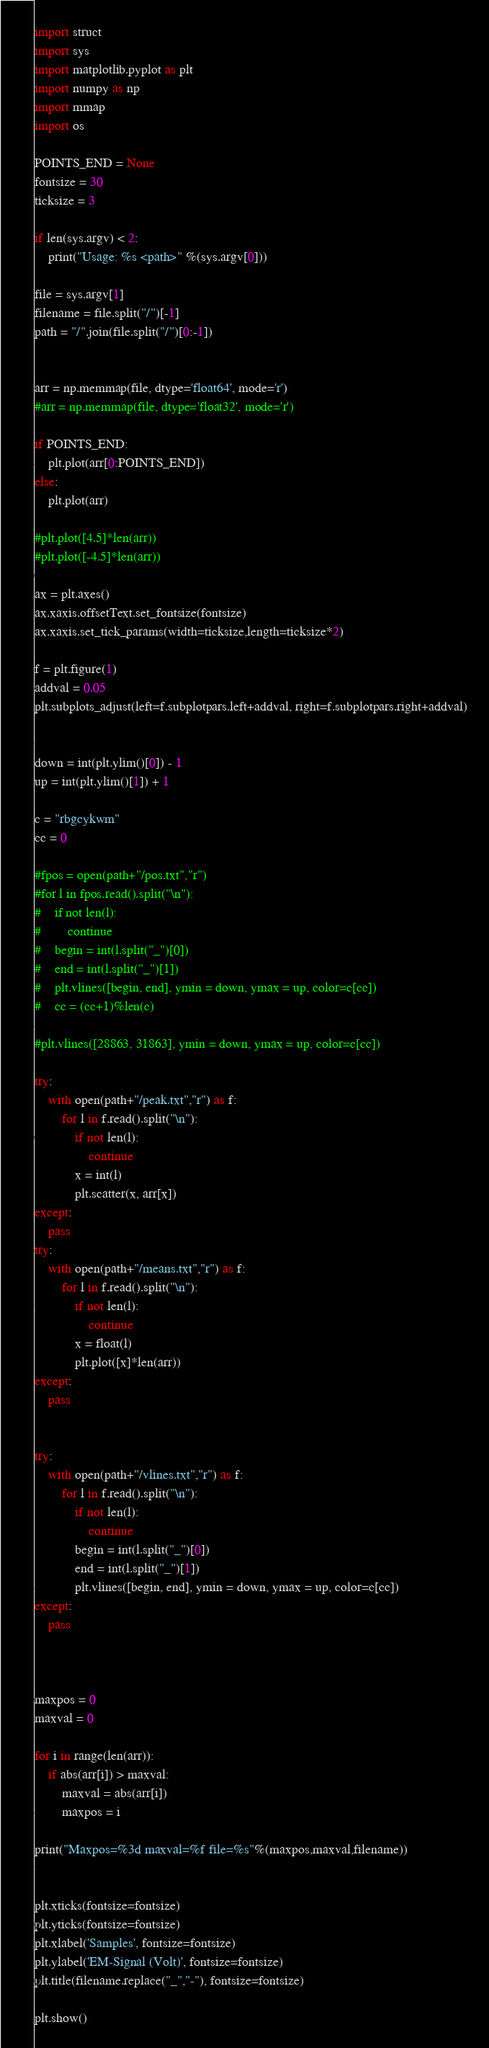<code> <loc_0><loc_0><loc_500><loc_500><_Python_>import struct
import sys
import matplotlib.pyplot as plt
import numpy as np
import mmap
import os

POINTS_END = None
fontsize = 30
ticksize = 3

if len(sys.argv) < 2:
    print("Usage: %s <path>" %(sys.argv[0]))

file = sys.argv[1]
filename = file.split("/")[-1]
path = "/".join(file.split("/")[0:-1])


arr = np.memmap(file, dtype='float64', mode='r')
#arr = np.memmap(file, dtype='float32', mode='r')

if POINTS_END:
    plt.plot(arr[0:POINTS_END])
else:
    plt.plot(arr)
    
#plt.plot([4.5]*len(arr))
#plt.plot([-4.5]*len(arr))

ax = plt.axes()
ax.xaxis.offsetText.set_fontsize(fontsize)
ax.xaxis.set_tick_params(width=ticksize,length=ticksize*2)

f = plt.figure(1)
addval = 0.05
plt.subplots_adjust(left=f.subplotpars.left+addval, right=f.subplotpars.right+addval)


down = int(plt.ylim()[0]) - 1
up = int(plt.ylim()[1]) + 1

c = "rbgcykwm"
cc = 0

#fpos = open(path+"/pos.txt","r")
#for l in fpos.read().split("\n"):
#    if not len(l):
#        continue
#    begin = int(l.split("_")[0])
#    end = int(l.split("_")[1])
#    plt.vlines([begin, end], ymin = down, ymax = up, color=c[cc])
#    cc = (cc+1)%len(c)

#plt.vlines([28863, 31863], ymin = down, ymax = up, color=c[cc])

try:
    with open(path+"/peak.txt","r") as f:
        for l in f.read().split("\n"):
            if not len(l):
                continue
            x = int(l)
            plt.scatter(x, arr[x])
except:
    pass
try:
    with open(path+"/means.txt","r") as f:
        for l in f.read().split("\n"):
            if not len(l):
                continue
            x = float(l)
            plt.plot([x]*len(arr))
except:
    pass


try:
    with open(path+"/vlines.txt","r") as f:
        for l in f.read().split("\n"):
            if not len(l):
                continue
            begin = int(l.split("_")[0])
            end = int(l.split("_")[1])
            plt.vlines([begin, end], ymin = down, ymax = up, color=c[cc])
except:
    pass



maxpos = 0
maxval = 0

for i in range(len(arr)):
    if abs(arr[i]) > maxval:
        maxval = abs(arr[i])
        maxpos = i

print("Maxpos=%3d maxval=%f file=%s"%(maxpos,maxval,filename))


plt.xticks(fontsize=fontsize)
plt.yticks(fontsize=fontsize)
plt.xlabel('Samples', fontsize=fontsize)
plt.ylabel('EM-Signal (Volt)', fontsize=fontsize)
plt.title(filename.replace("_","-"), fontsize=fontsize)

plt.show()
</code> 